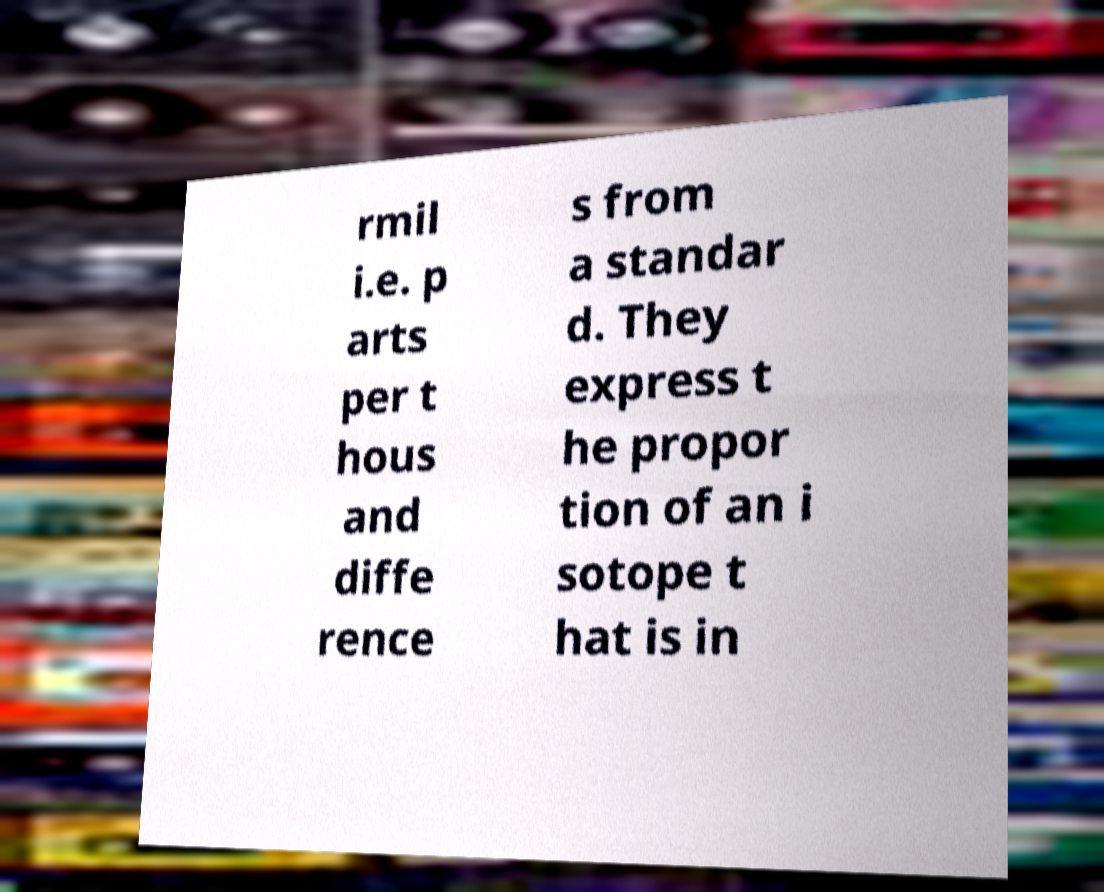There's text embedded in this image that I need extracted. Can you transcribe it verbatim? rmil i.e. p arts per t hous and diffe rence s from a standar d. They express t he propor tion of an i sotope t hat is in 